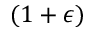Convert formula to latex. <formula><loc_0><loc_0><loc_500><loc_500>( 1 + \epsilon )</formula> 